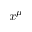Convert formula to latex. <formula><loc_0><loc_0><loc_500><loc_500>x ^ { \mu }</formula> 